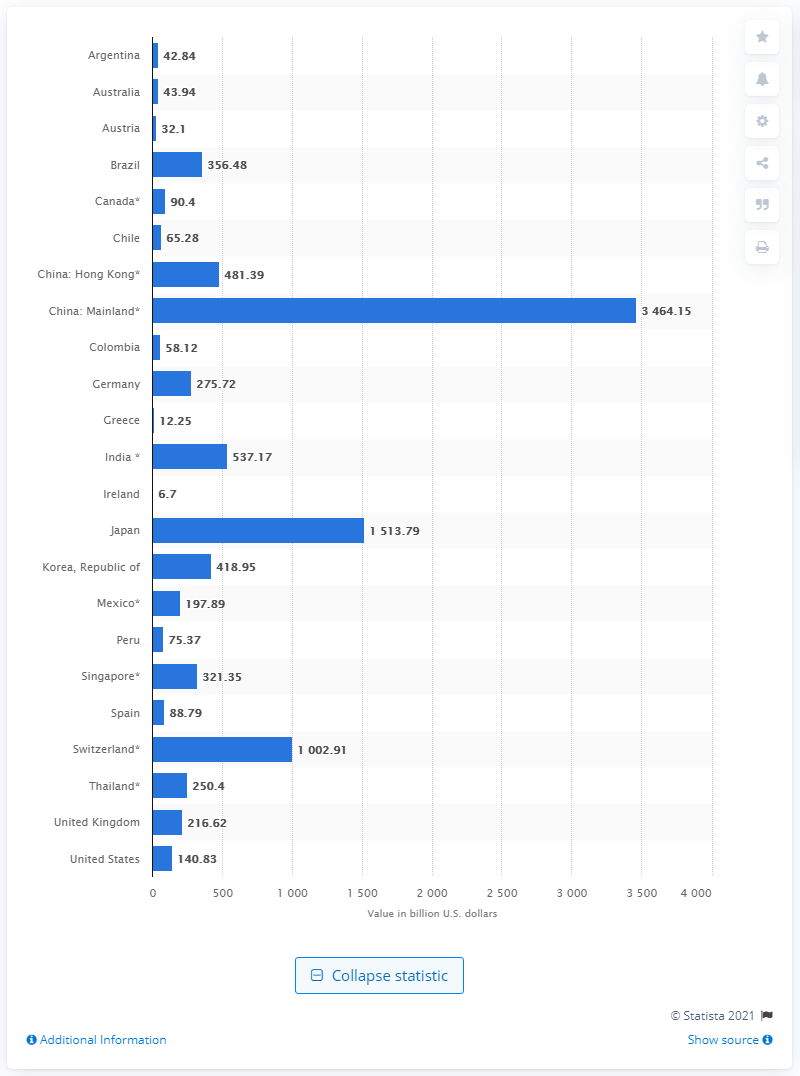How many U.S. dollars did China have in reserves in August 2020?
 3464.15 